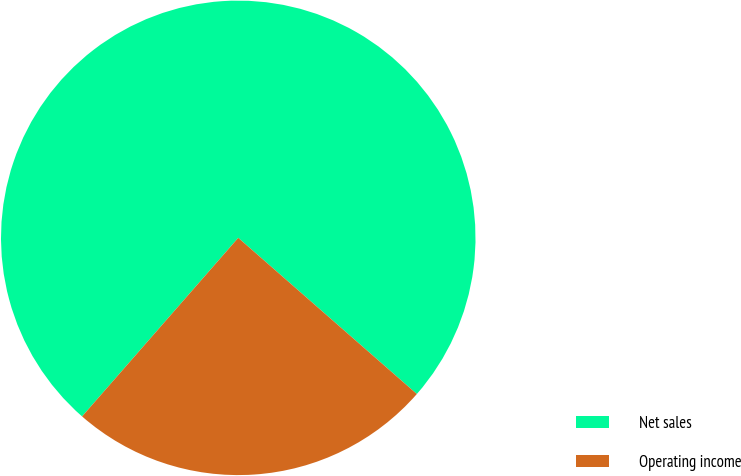Convert chart. <chart><loc_0><loc_0><loc_500><loc_500><pie_chart><fcel>Net sales<fcel>Operating income<nl><fcel>75.0%<fcel>25.0%<nl></chart> 